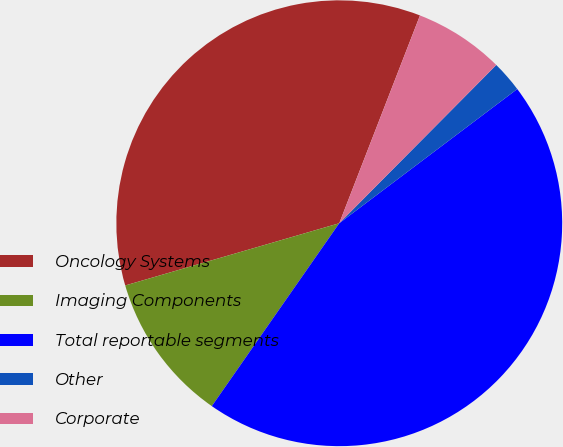Convert chart. <chart><loc_0><loc_0><loc_500><loc_500><pie_chart><fcel>Oncology Systems<fcel>Imaging Components<fcel>Total reportable segments<fcel>Other<fcel>Corporate<nl><fcel>35.4%<fcel>10.81%<fcel>44.97%<fcel>2.28%<fcel>6.54%<nl></chart> 